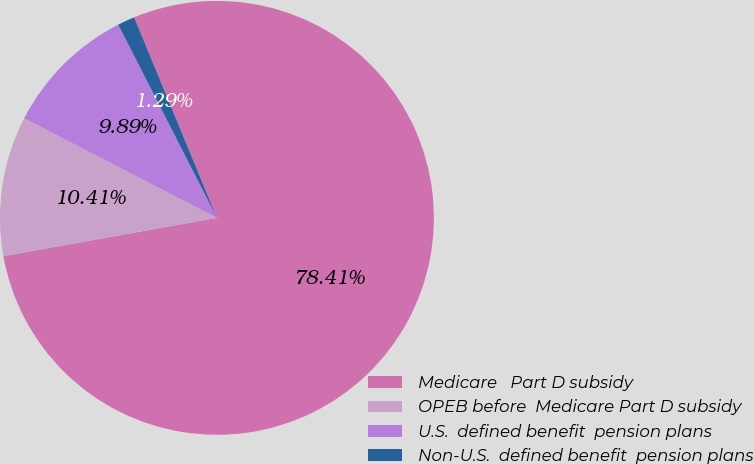Convert chart. <chart><loc_0><loc_0><loc_500><loc_500><pie_chart><fcel>Medicare   Part D subsidy<fcel>OPEB before  Medicare Part D subsidy<fcel>U.S.  defined benefit  pension plans<fcel>Non-U.S.  defined benefit  pension plans<nl><fcel>78.4%<fcel>10.41%<fcel>9.89%<fcel>1.29%<nl></chart> 